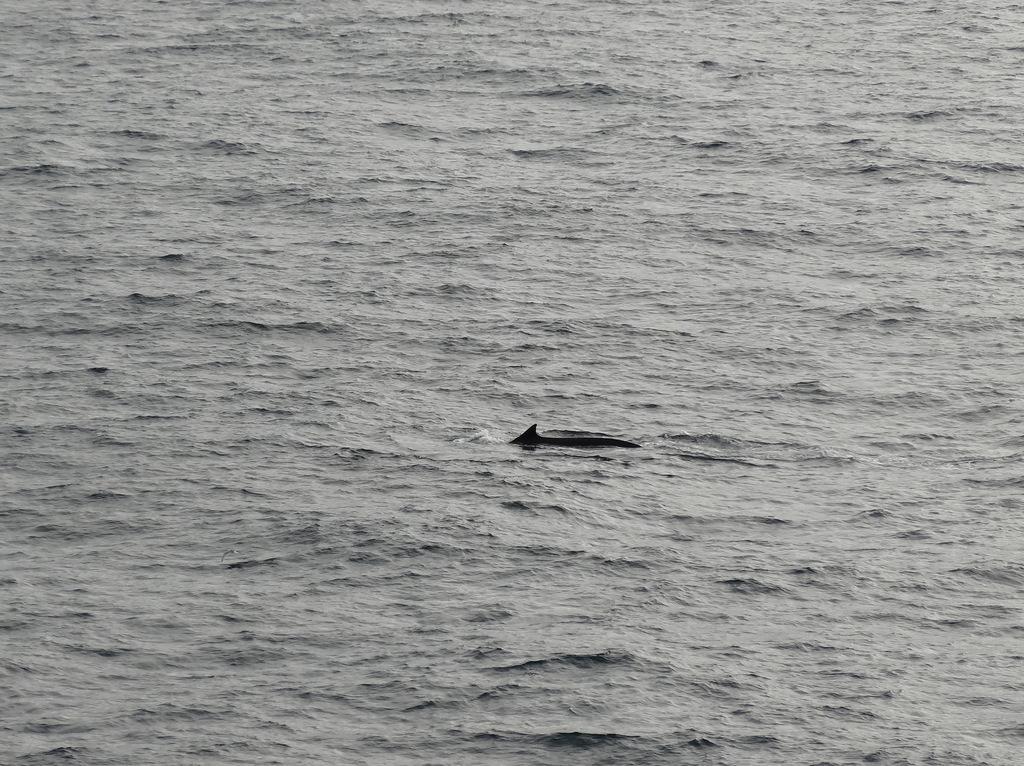Can you describe this image briefly? In the image there is a sea and some animal is swimming in the sea. 